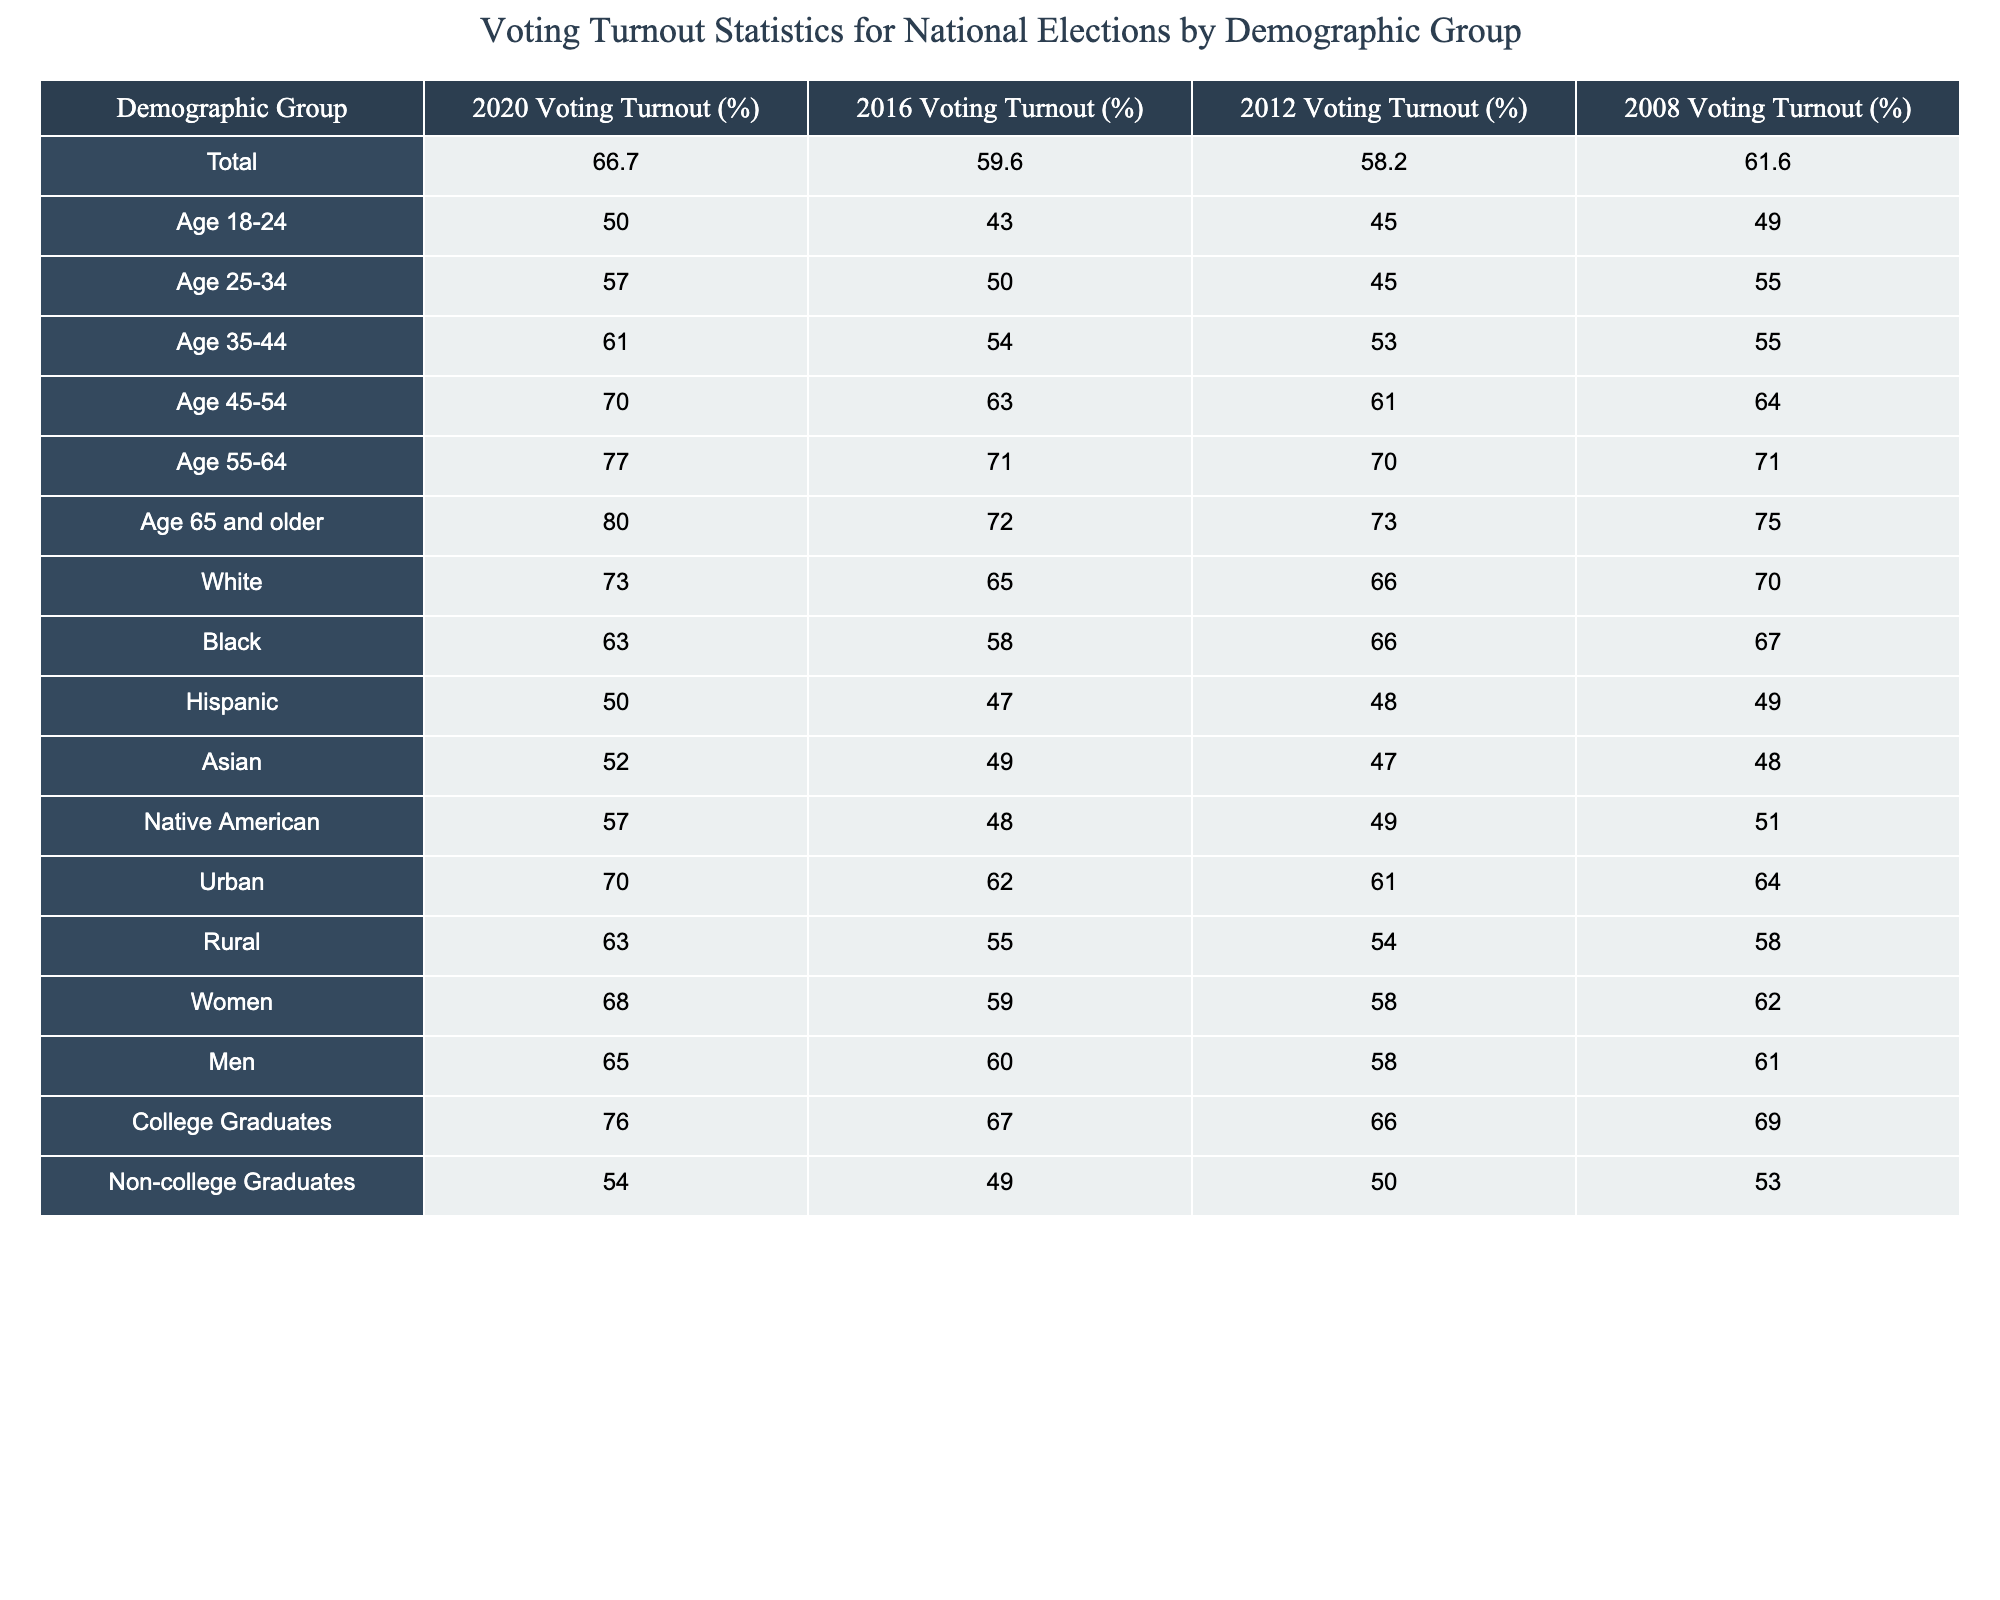What was the voting turnout for the demographic group aged 18-24 in 2020? According to the table, the voting turnout for the age group 18-24 in 2020 is listed as 50.0%.
Answer: 50.0% What percentage of college graduates voted in 2020 compared to non-college graduates? The voting turnout for college graduates in 2020 was 76.0%, while for non-college graduates it was 54.0%. Therefore, college graduates had a higher turnout by a difference of 76.0% - 54.0% = 22.0%.
Answer: 76.0% (College Graduates) vs 54.0% (Non-college Graduates) Did the voting turnout for Black voters increase from 2016 to 2020? The voting turnout for Black voters was 58.0% in 2016 and increased to 63.0% in 2020. Since 63.0% is greater than 58.0%, it confirms that the turnout did increase.
Answer: Yes What was the average voting turnout for the age groups 35-44, 45-54, and 55-64 in 2020? The voting turnout for age groups 35-44, 45-54, and 55-64 in 2020 was 61.0%, 70.0%, and 77.0% respectively. To find the average, we sum these values: 61.0 + 70.0 + 77.0 = 208.0 and then divide by 3 to get 208.0 / 3 = 69.33.
Answer: 69.33% What is the difference in voting turnout between urban and rural areas in 2020? The voting turnout for urban areas in 2020 is 70.0% while for rural areas it is 63.0%. To find the difference, subtract the rural turnout from the urban turnout: 70.0% - 63.0% = 7.0%.
Answer: 7.0% Which demographic group had the highest voting turnout in 2020? In the table, the highest voting turnout listed is for the demographic group aged 65 and older at 80.0%.
Answer: 80.0% Was the voting turnout for Hispanic voters higher in 2016 than in 2012? The voting turnout for Hispanic voters was 47.0% in 2016 and 48.0% in 2012. Since 47.0% is less than 48.0%, it indicates that the turnout in 2016 was not higher than in 2012.
Answer: No What is the percentage increase in voting turnout for the 55-64 age group from 2008 to 2020? The voting turnout for the 55-64 age group was 71.0% in 2008 and increased to 77.0% in 2020. The increase is calculated as (77.0% - 71.0%) / 71.0% * 100 = 8.45%.
Answer: 8.45% How much did the overall voting turnout increase from 2016 to 2020? The overall voting turnout increased from 59.6% in 2016 to 66.7% in 2020. The increase is calculated as 66.7% - 59.6% = 7.1%.
Answer: 7.1% 